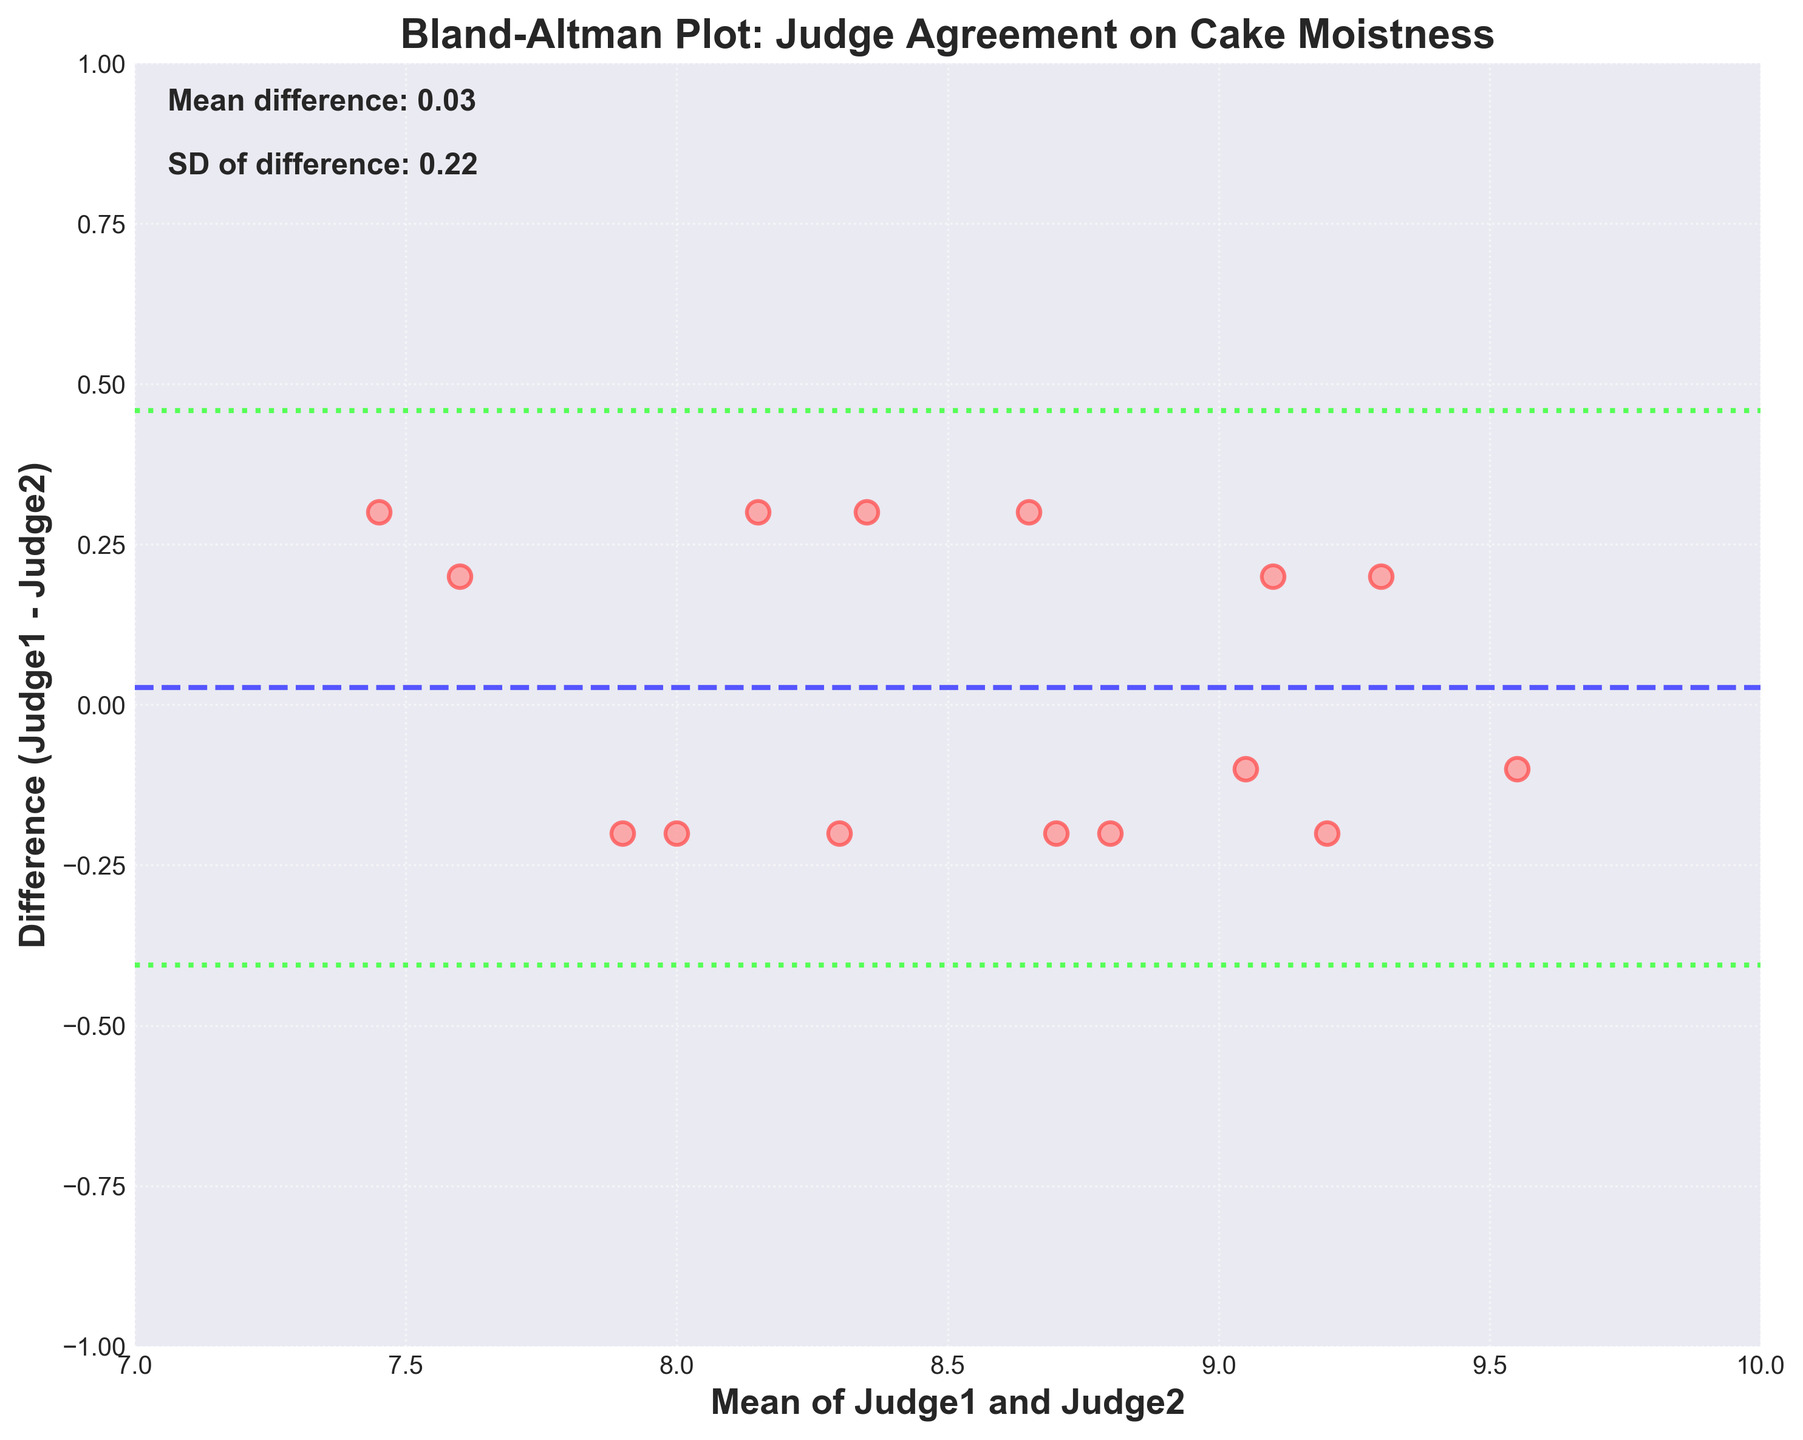What is the title of the plot? The title of the plot is displayed at the top of the figure. It reads 'Bland-Altman Plot: Judge Agreement on Cake Moistness'.
Answer: Bland-Altman Plot: Judge Agreement on Cake Moistness How many data points are in the scatter plot? Each point in the scatter plot represents a pair of moistness scores from the two judges. Counting these points, there are 15 data points.
Answer: 15 What do the dashed lines represent? In a Bland-Altman plot, the dashed lines represent the mean difference between the two judges' scores and the limits of agreement, which are the mean difference plus and minus 1.96 times the standard deviation. There are three dashed lines: one blue in the center (mean difference) and two green ones above and below it (limits of agreement).
Answer: Mean difference and limits of agreement What is the mean difference between the judges' moistness scores? There is a text annotation on the plot that specifically says 'Mean difference: -0.09'. This is the average difference between Judge1 and Judge2 scores.
Answer: -0.09 What do the limits of agreement indicate in this plot? The limits of agreement define the range within which 95% of the differences between the judges' scores are expected to lie. These are calculated as the mean difference ± 1.96 times the standard deviation.
Answer: Range of 95% of score differences What color are the data points in the scatter plot? The data points are visually represented in a pinkish color, with detailed highlights around the edges in a slightly darker pink.
Answer: Pink Does Judge1 generally score higher or lower than Judge2? To determine if Judge1 scores higher or lower on average, note the mean difference value provided as -0.09, which indicates that Judge1 scores slightly lower than Judge2 overall, as it's a negative value.
Answer: Lower What is the standard deviation of the differences between the judges' scores? As indicated by the text annotation on the plot, the standard deviation of the differences is 'SD of difference: 0.18'.
Answer: 0.18 What is the range of the x-axis, which represents the mean of Judge1 and Judge2? The x-axis ranges from 7 to 10, indicating that average scores from both judges stretch within this interval.
Answer: 7 to 10 What does the y-axis denote? The y-axis in the Bland-Altman plot indicates the differences between the scores given by Judge1 and Judge2 (Judge1 - Judge2).
Answer: Differences between Judge1 and Judge2 